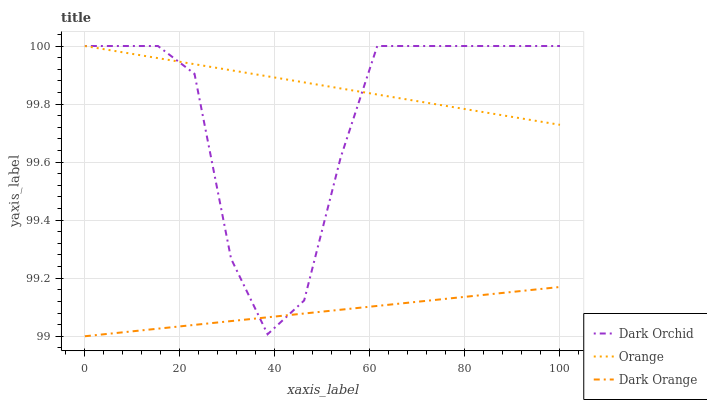Does Dark Orange have the minimum area under the curve?
Answer yes or no. Yes. Does Orange have the maximum area under the curve?
Answer yes or no. Yes. Does Dark Orchid have the minimum area under the curve?
Answer yes or no. No. Does Dark Orchid have the maximum area under the curve?
Answer yes or no. No. Is Orange the smoothest?
Answer yes or no. Yes. Is Dark Orchid the roughest?
Answer yes or no. Yes. Is Dark Orange the smoothest?
Answer yes or no. No. Is Dark Orange the roughest?
Answer yes or no. No. Does Dark Orange have the lowest value?
Answer yes or no. Yes. Does Dark Orchid have the lowest value?
Answer yes or no. No. Does Dark Orchid have the highest value?
Answer yes or no. Yes. Does Dark Orange have the highest value?
Answer yes or no. No. Is Dark Orange less than Orange?
Answer yes or no. Yes. Is Orange greater than Dark Orange?
Answer yes or no. Yes. Does Dark Orchid intersect Dark Orange?
Answer yes or no. Yes. Is Dark Orchid less than Dark Orange?
Answer yes or no. No. Is Dark Orchid greater than Dark Orange?
Answer yes or no. No. Does Dark Orange intersect Orange?
Answer yes or no. No. 